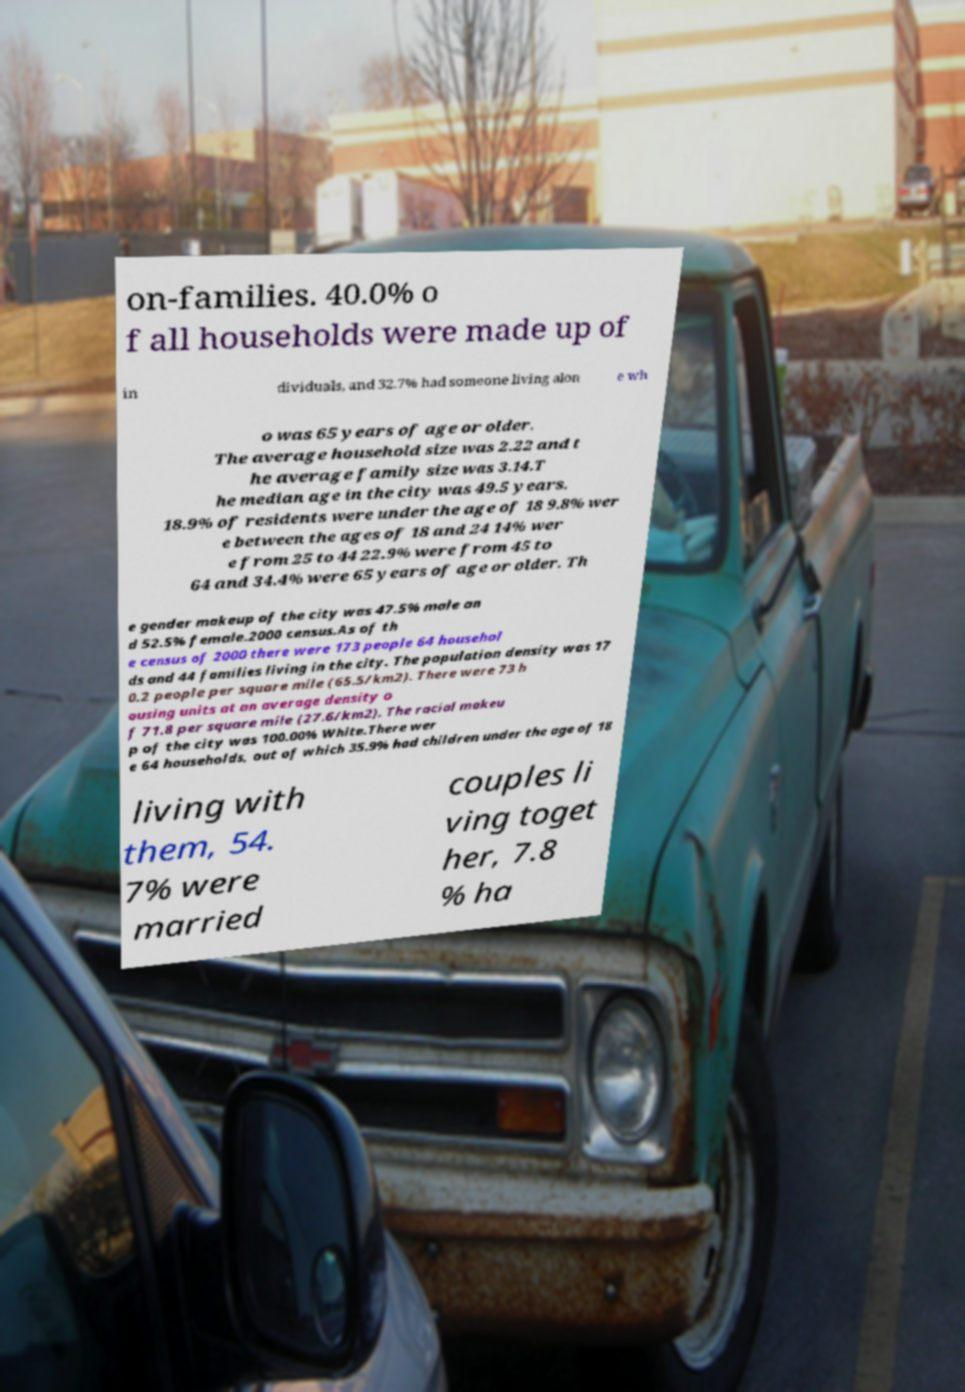What messages or text are displayed in this image? I need them in a readable, typed format. on-families. 40.0% o f all households were made up of in dividuals, and 32.7% had someone living alon e wh o was 65 years of age or older. The average household size was 2.22 and t he average family size was 3.14.T he median age in the city was 49.5 years. 18.9% of residents were under the age of 18 9.8% wer e between the ages of 18 and 24 14% wer e from 25 to 44 22.9% were from 45 to 64 and 34.4% were 65 years of age or older. Th e gender makeup of the city was 47.5% male an d 52.5% female.2000 census.As of th e census of 2000 there were 173 people 64 househol ds and 44 families living in the city. The population density was 17 0.2 people per square mile (65.5/km2). There were 73 h ousing units at an average density o f 71.8 per square mile (27.6/km2). The racial makeu p of the city was 100.00% White.There wer e 64 households, out of which 35.9% had children under the age of 18 living with them, 54. 7% were married couples li ving toget her, 7.8 % ha 